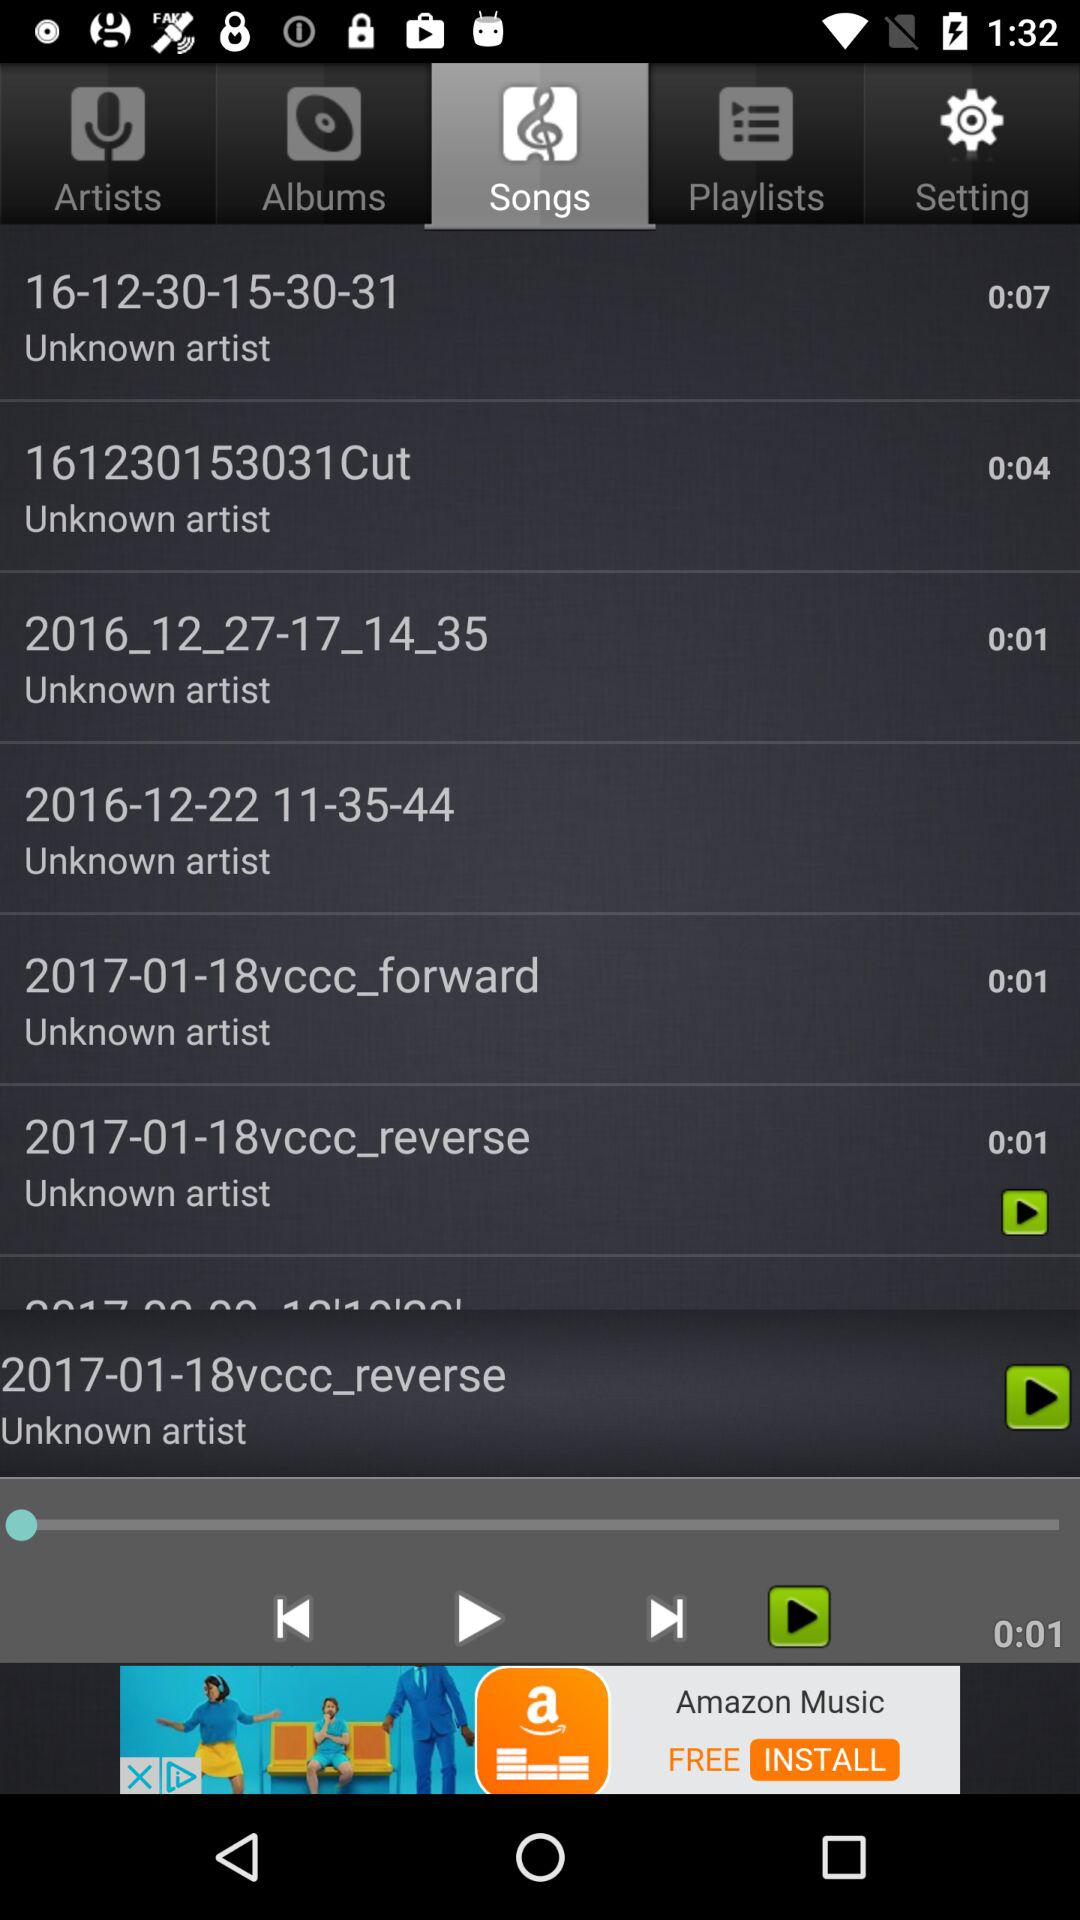What time duration is given for the "161230153031Cut" song? The given time duration is 4 seconds. 